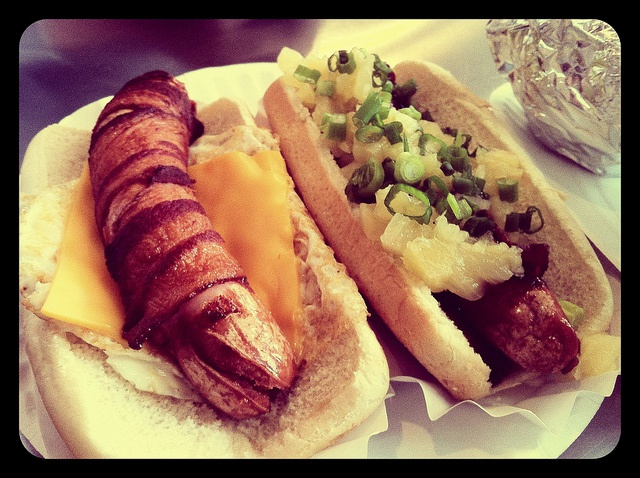Describe the objects in this image and their specific colors. I can see hot dog in black, khaki, tan, maroon, and brown tones and hot dog in black, tan, brown, and maroon tones in this image. 